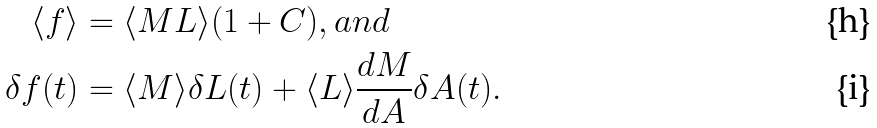Convert formula to latex. <formula><loc_0><loc_0><loc_500><loc_500>\langle f \rangle & = \langle M L \rangle ( 1 + C ) , a n d \\ \delta f ( t ) & = \langle M \rangle \delta L ( t ) + \langle L \rangle \frac { d M } { d A } \delta A ( t ) .</formula> 